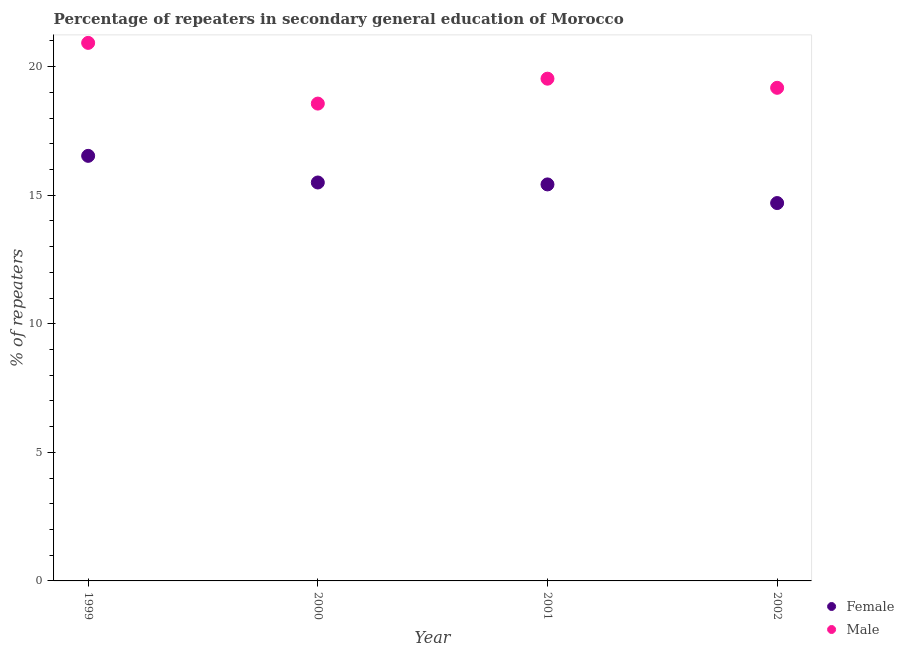What is the percentage of male repeaters in 2001?
Give a very brief answer. 19.53. Across all years, what is the maximum percentage of male repeaters?
Your answer should be compact. 20.93. Across all years, what is the minimum percentage of male repeaters?
Make the answer very short. 18.57. In which year was the percentage of male repeaters maximum?
Offer a very short reply. 1999. In which year was the percentage of male repeaters minimum?
Ensure brevity in your answer.  2000. What is the total percentage of male repeaters in the graph?
Your answer should be very brief. 78.2. What is the difference between the percentage of male repeaters in 2000 and that in 2002?
Your answer should be very brief. -0.61. What is the difference between the percentage of female repeaters in 1999 and the percentage of male repeaters in 2000?
Offer a very short reply. -2.03. What is the average percentage of female repeaters per year?
Your response must be concise. 15.54. In the year 2001, what is the difference between the percentage of male repeaters and percentage of female repeaters?
Give a very brief answer. 4.11. What is the ratio of the percentage of female repeaters in 2000 to that in 2001?
Offer a very short reply. 1. What is the difference between the highest and the second highest percentage of female repeaters?
Your response must be concise. 1.04. What is the difference between the highest and the lowest percentage of male repeaters?
Your answer should be very brief. 2.36. Is the sum of the percentage of female repeaters in 2000 and 2001 greater than the maximum percentage of male repeaters across all years?
Provide a succinct answer. Yes. Does the percentage of male repeaters monotonically increase over the years?
Provide a succinct answer. No. Is the percentage of female repeaters strictly greater than the percentage of male repeaters over the years?
Provide a succinct answer. No. How many dotlines are there?
Ensure brevity in your answer.  2. What is the difference between two consecutive major ticks on the Y-axis?
Your answer should be compact. 5. Are the values on the major ticks of Y-axis written in scientific E-notation?
Your answer should be very brief. No. Does the graph contain any zero values?
Make the answer very short. No. Where does the legend appear in the graph?
Provide a succinct answer. Bottom right. What is the title of the graph?
Give a very brief answer. Percentage of repeaters in secondary general education of Morocco. What is the label or title of the X-axis?
Give a very brief answer. Year. What is the label or title of the Y-axis?
Provide a succinct answer. % of repeaters. What is the % of repeaters in Female in 1999?
Offer a very short reply. 16.53. What is the % of repeaters of Male in 1999?
Offer a very short reply. 20.93. What is the % of repeaters in Female in 2000?
Your response must be concise. 15.5. What is the % of repeaters of Male in 2000?
Provide a short and direct response. 18.57. What is the % of repeaters of Female in 2001?
Offer a terse response. 15.42. What is the % of repeaters of Male in 2001?
Offer a terse response. 19.53. What is the % of repeaters of Female in 2002?
Your response must be concise. 14.7. What is the % of repeaters in Male in 2002?
Offer a very short reply. 19.18. Across all years, what is the maximum % of repeaters of Female?
Your answer should be compact. 16.53. Across all years, what is the maximum % of repeaters of Male?
Your response must be concise. 20.93. Across all years, what is the minimum % of repeaters in Female?
Give a very brief answer. 14.7. Across all years, what is the minimum % of repeaters in Male?
Offer a very short reply. 18.57. What is the total % of repeaters in Female in the graph?
Provide a succinct answer. 62.15. What is the total % of repeaters of Male in the graph?
Your answer should be very brief. 78.2. What is the difference between the % of repeaters of Female in 1999 and that in 2000?
Make the answer very short. 1.04. What is the difference between the % of repeaters in Male in 1999 and that in 2000?
Keep it short and to the point. 2.36. What is the difference between the % of repeaters in Female in 1999 and that in 2001?
Give a very brief answer. 1.11. What is the difference between the % of repeaters of Male in 1999 and that in 2001?
Make the answer very short. 1.39. What is the difference between the % of repeaters of Female in 1999 and that in 2002?
Your response must be concise. 1.84. What is the difference between the % of repeaters in Male in 1999 and that in 2002?
Your response must be concise. 1.75. What is the difference between the % of repeaters in Female in 2000 and that in 2001?
Offer a very short reply. 0.07. What is the difference between the % of repeaters in Male in 2000 and that in 2001?
Make the answer very short. -0.97. What is the difference between the % of repeaters of Female in 2000 and that in 2002?
Your answer should be compact. 0.8. What is the difference between the % of repeaters in Male in 2000 and that in 2002?
Keep it short and to the point. -0.61. What is the difference between the % of repeaters in Female in 2001 and that in 2002?
Your response must be concise. 0.72. What is the difference between the % of repeaters in Male in 2001 and that in 2002?
Your response must be concise. 0.36. What is the difference between the % of repeaters in Female in 1999 and the % of repeaters in Male in 2000?
Keep it short and to the point. -2.03. What is the difference between the % of repeaters in Female in 1999 and the % of repeaters in Male in 2001?
Provide a succinct answer. -3. What is the difference between the % of repeaters in Female in 1999 and the % of repeaters in Male in 2002?
Offer a very short reply. -2.65. What is the difference between the % of repeaters in Female in 2000 and the % of repeaters in Male in 2001?
Give a very brief answer. -4.04. What is the difference between the % of repeaters in Female in 2000 and the % of repeaters in Male in 2002?
Keep it short and to the point. -3.68. What is the difference between the % of repeaters in Female in 2001 and the % of repeaters in Male in 2002?
Your response must be concise. -3.76. What is the average % of repeaters of Female per year?
Offer a terse response. 15.54. What is the average % of repeaters in Male per year?
Offer a very short reply. 19.55. In the year 1999, what is the difference between the % of repeaters in Female and % of repeaters in Male?
Keep it short and to the point. -4.39. In the year 2000, what is the difference between the % of repeaters of Female and % of repeaters of Male?
Your response must be concise. -3.07. In the year 2001, what is the difference between the % of repeaters of Female and % of repeaters of Male?
Provide a succinct answer. -4.11. In the year 2002, what is the difference between the % of repeaters of Female and % of repeaters of Male?
Offer a terse response. -4.48. What is the ratio of the % of repeaters in Female in 1999 to that in 2000?
Offer a terse response. 1.07. What is the ratio of the % of repeaters in Male in 1999 to that in 2000?
Give a very brief answer. 1.13. What is the ratio of the % of repeaters of Female in 1999 to that in 2001?
Offer a terse response. 1.07. What is the ratio of the % of repeaters of Male in 1999 to that in 2001?
Ensure brevity in your answer.  1.07. What is the ratio of the % of repeaters in Female in 1999 to that in 2002?
Make the answer very short. 1.12. What is the ratio of the % of repeaters in Male in 1999 to that in 2002?
Ensure brevity in your answer.  1.09. What is the ratio of the % of repeaters of Female in 2000 to that in 2001?
Offer a terse response. 1. What is the ratio of the % of repeaters of Male in 2000 to that in 2001?
Your answer should be compact. 0.95. What is the ratio of the % of repeaters of Female in 2000 to that in 2002?
Give a very brief answer. 1.05. What is the ratio of the % of repeaters of Female in 2001 to that in 2002?
Offer a very short reply. 1.05. What is the ratio of the % of repeaters in Male in 2001 to that in 2002?
Your answer should be very brief. 1.02. What is the difference between the highest and the second highest % of repeaters of Female?
Your answer should be very brief. 1.04. What is the difference between the highest and the second highest % of repeaters of Male?
Offer a terse response. 1.39. What is the difference between the highest and the lowest % of repeaters in Female?
Your response must be concise. 1.84. What is the difference between the highest and the lowest % of repeaters of Male?
Provide a succinct answer. 2.36. 